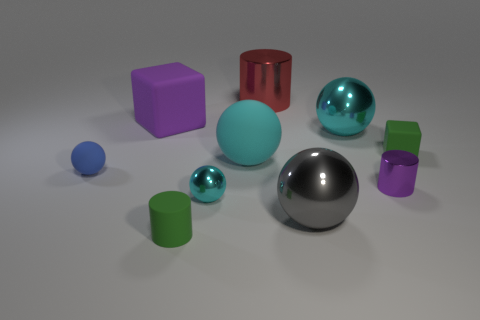Subtract all cyan balls. How many were subtracted if there are1cyan balls left? 2 Subtract all cyan blocks. How many cyan spheres are left? 3 Subtract 1 spheres. How many spheres are left? 4 Subtract all large cyan rubber balls. How many balls are left? 4 Subtract all blue balls. How many balls are left? 4 Subtract all red spheres. Subtract all cyan blocks. How many spheres are left? 5 Subtract all blocks. How many objects are left? 8 Add 9 tiny gray metallic balls. How many tiny gray metallic balls exist? 9 Subtract 0 yellow cylinders. How many objects are left? 10 Subtract all small green matte cubes. Subtract all large cyan rubber spheres. How many objects are left? 8 